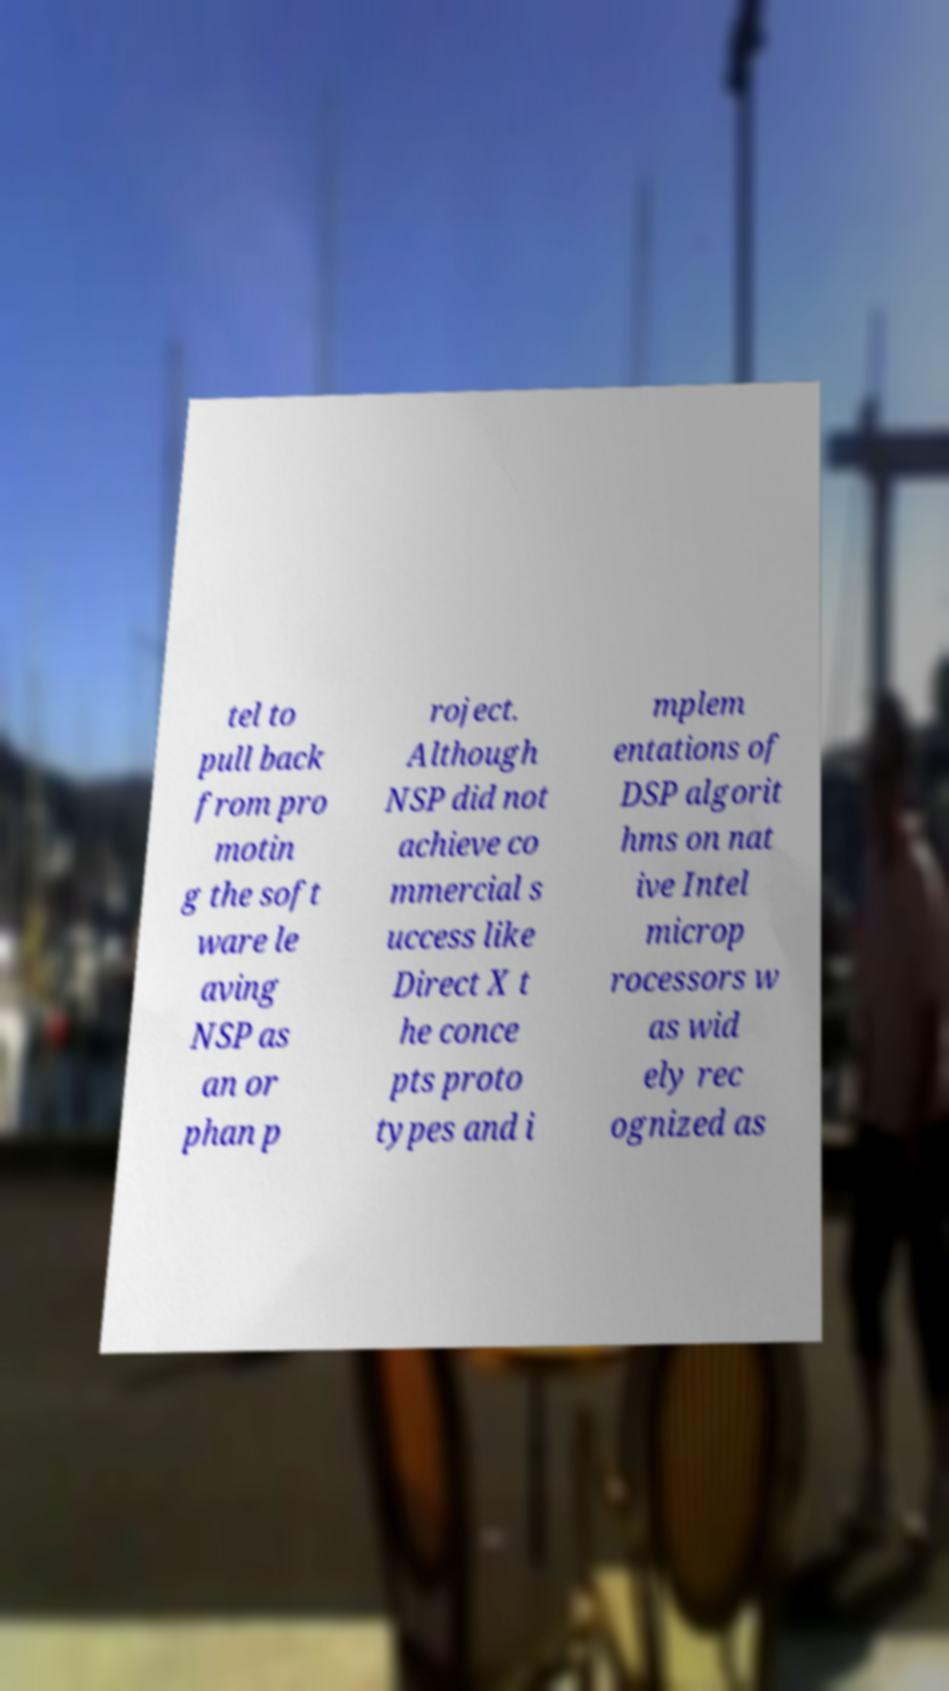I need the written content from this picture converted into text. Can you do that? tel to pull back from pro motin g the soft ware le aving NSP as an or phan p roject. Although NSP did not achieve co mmercial s uccess like Direct X t he conce pts proto types and i mplem entations of DSP algorit hms on nat ive Intel microp rocessors w as wid ely rec ognized as 